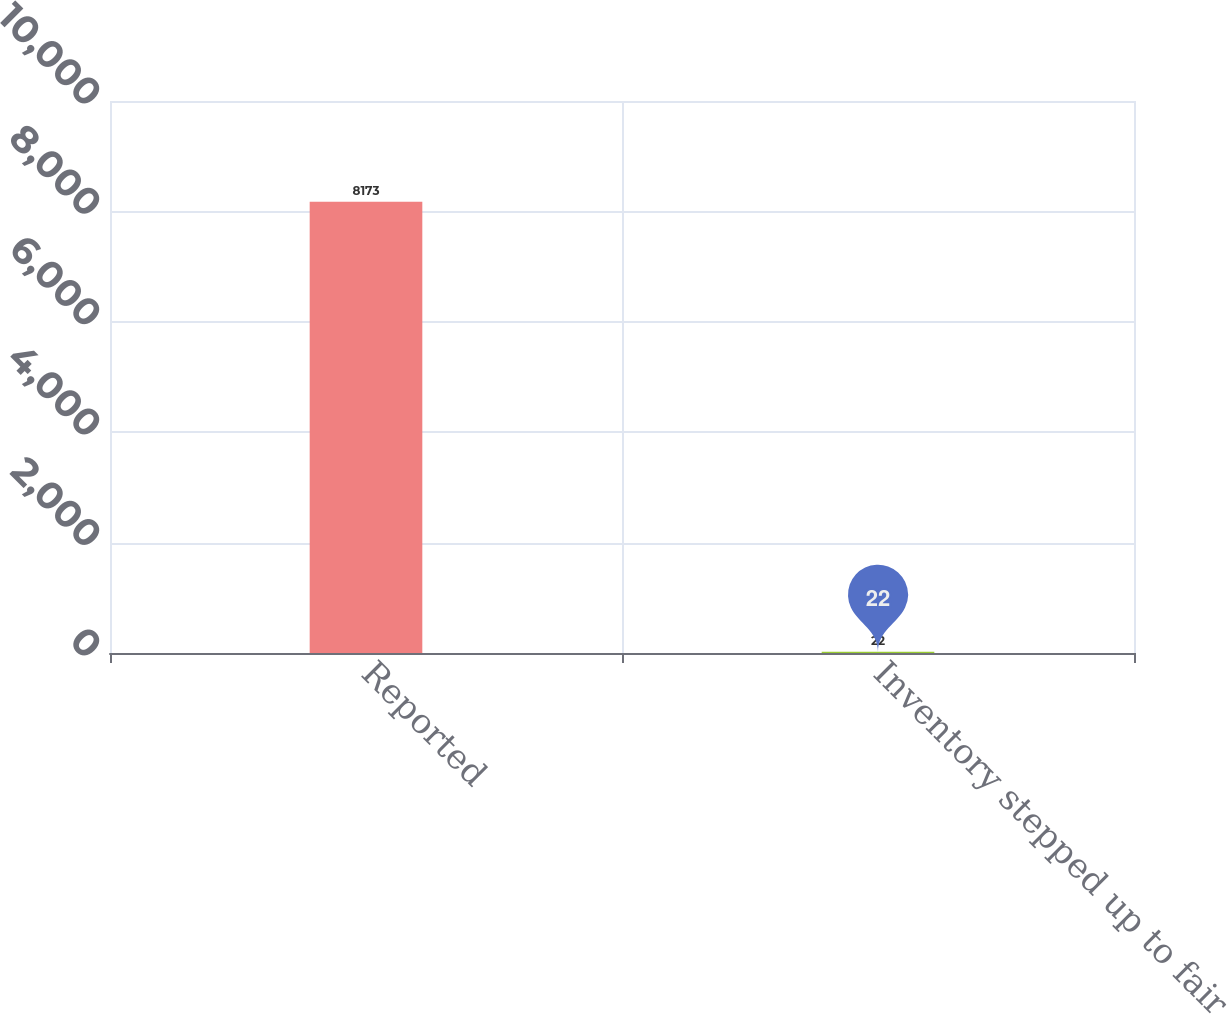Convert chart to OTSL. <chart><loc_0><loc_0><loc_500><loc_500><bar_chart><fcel>Reported<fcel>Inventory stepped up to fair<nl><fcel>8173<fcel>22<nl></chart> 